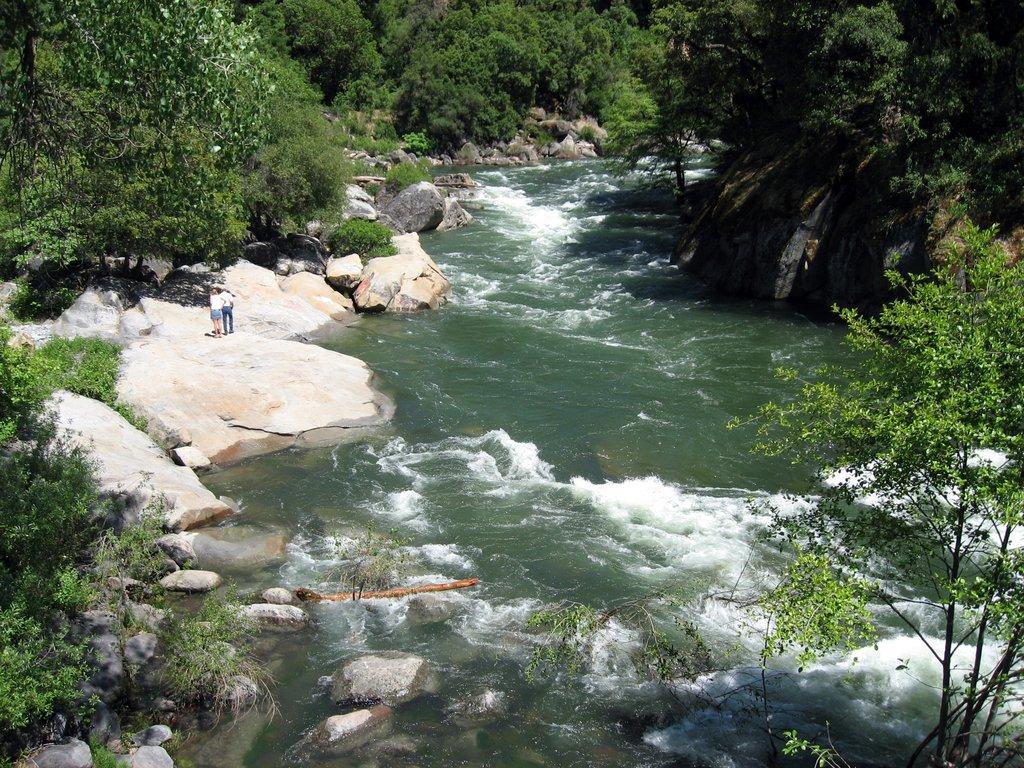Could you give a brief overview of what you see in this image? This image is clicked outside. There are trees all sides of image. There is water in the middle. There are two persons on the left side. There are so many rocks in this image on the left side. 